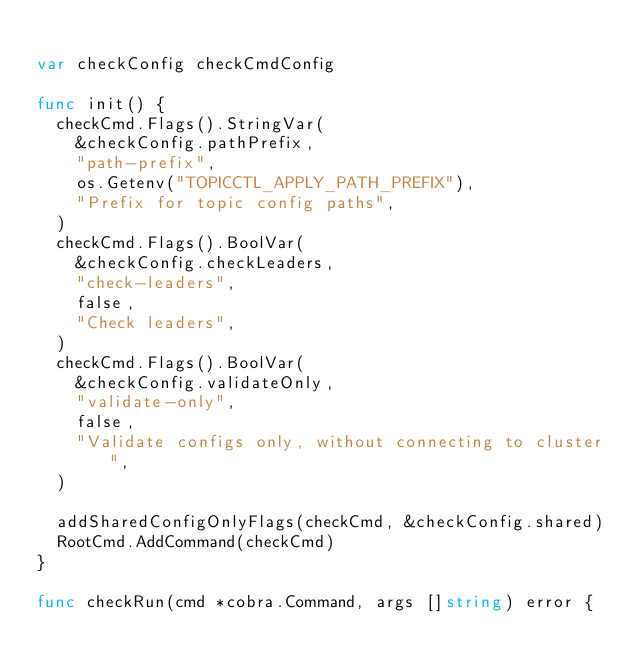Convert code to text. <code><loc_0><loc_0><loc_500><loc_500><_Go_>
var checkConfig checkCmdConfig

func init() {
	checkCmd.Flags().StringVar(
		&checkConfig.pathPrefix,
		"path-prefix",
		os.Getenv("TOPICCTL_APPLY_PATH_PREFIX"),
		"Prefix for topic config paths",
	)
	checkCmd.Flags().BoolVar(
		&checkConfig.checkLeaders,
		"check-leaders",
		false,
		"Check leaders",
	)
	checkCmd.Flags().BoolVar(
		&checkConfig.validateOnly,
		"validate-only",
		false,
		"Validate configs only, without connecting to cluster",
	)

	addSharedConfigOnlyFlags(checkCmd, &checkConfig.shared)
	RootCmd.AddCommand(checkCmd)
}

func checkRun(cmd *cobra.Command, args []string) error {</code> 